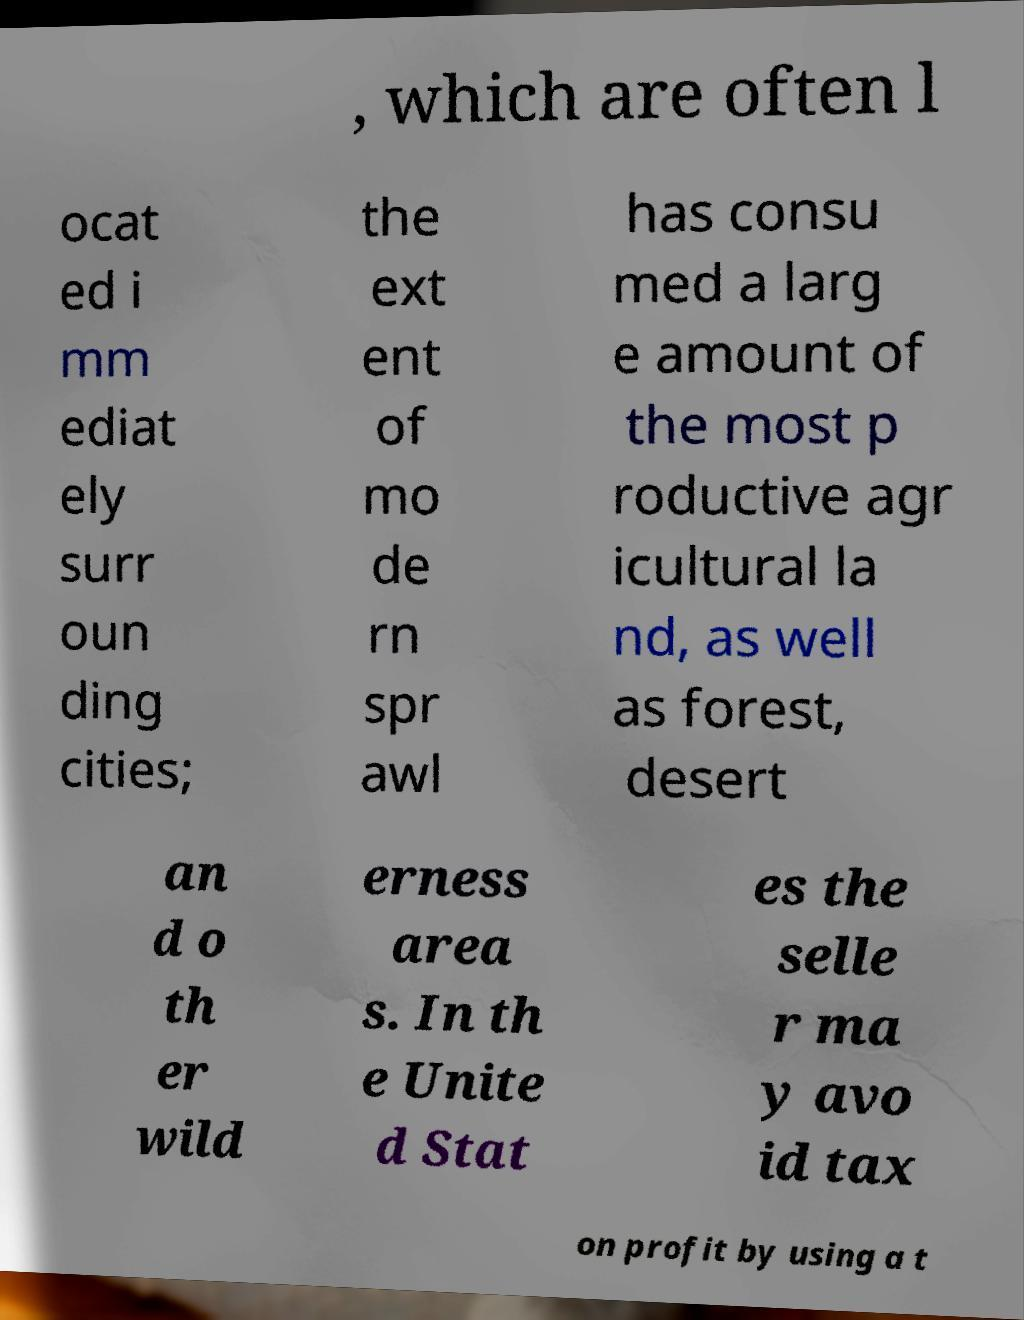Please identify and transcribe the text found in this image. , which are often l ocat ed i mm ediat ely surr oun ding cities; the ext ent of mo de rn spr awl has consu med a larg e amount of the most p roductive agr icultural la nd, as well as forest, desert an d o th er wild erness area s. In th e Unite d Stat es the selle r ma y avo id tax on profit by using a t 